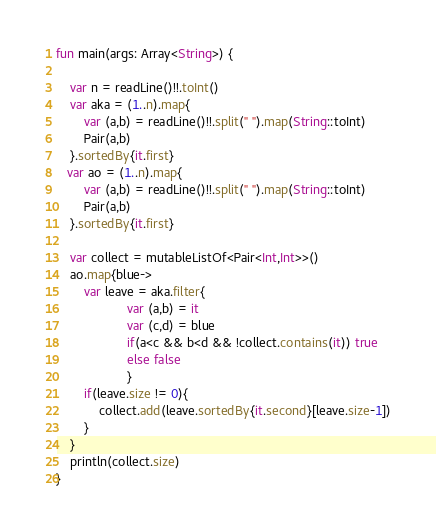Convert code to text. <code><loc_0><loc_0><loc_500><loc_500><_Kotlin_>fun main(args: Array<String>) {
    
    var n = readLine()!!.toInt()
    var aka = (1..n).map{
        var (a,b) = readLine()!!.split(" ").map(String::toInt)
        Pair(a,b)
    }.sortedBy{it.first}
   var ao = (1..n).map{
        var (a,b) = readLine()!!.split(" ").map(String::toInt)
        Pair(a,b)
    }.sortedBy{it.first}

    var collect = mutableListOf<Pair<Int,Int>>()
    ao.map{blue->
        var leave = aka.filter{
                    var (a,b) = it
                    var (c,d) = blue
                    if(a<c && b<d && !collect.contains(it)) true
                    else false
                    }
        if(leave.size != 0){
            collect.add(leave.sortedBy{it.second}[leave.size-1])
        }
    }
    println(collect.size)
}</code> 